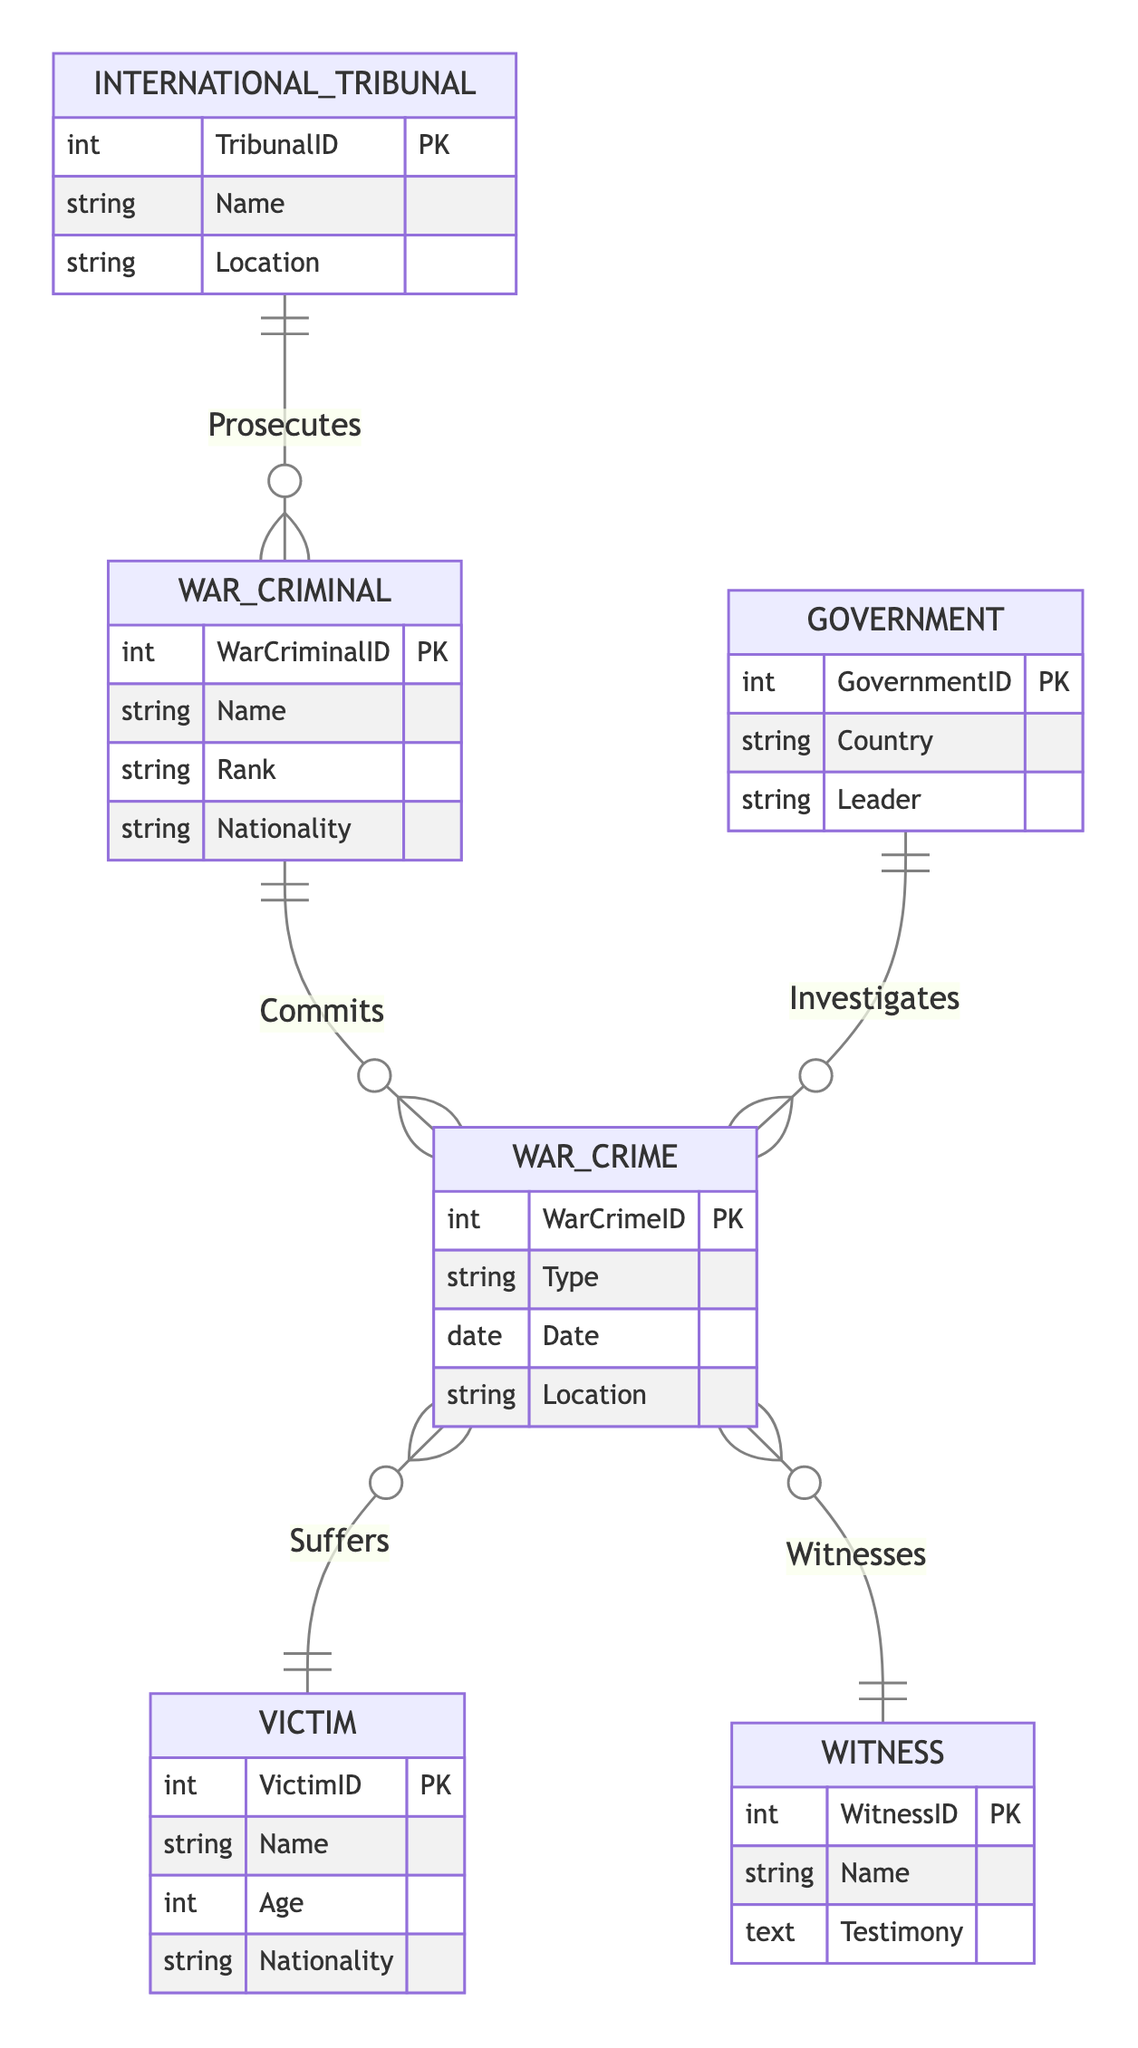What entity is involved in committing war crimes? The entity that represents individuals who commit war crimes is labeled "War Criminal". It directly connects to the "War Crime" entity through the "Commits" relationship.
Answer: War Criminal How many attributes does the War Crime entity have? The "War Crime" entity includes four attributes: WarCrimeID, Type, Date, and Location. By counting these, we find there are four attributes.
Answer: 4 What relationship connects Victims and War Crimes? The "Suffers" relationship connects "Victim" to "War Crime". This indicates that victims are those who are affected by war crimes.
Answer: Suffers Which entity prosecutes the War Criminals? The "International Tribunal" entity is responsible for prosecuting war criminals. It is connected to the "War Criminal" entity through the "Prosecutes" relationship.
Answer: International Tribunal What is the nature of the relationship between Government and War Crime? The relationship named "Investigates" establishes a link between "Government" and "War Crime". This indicates that governments take action to investigate war crimes.
Answer: Investigates How many entities are there in the diagram? By counting the listed entities—War Criminal, War Crime, Victim, Witness, International Tribunal, and Government—we find there are a total of six entities in the diagram.
Answer: 6 Which role does the Witness play in relation to War Crimes? The role of "Witness" is defined by the "Witnesses" relationship, which connects this entity to "War Crime". This means witnesses provide testimony regarding war crimes.
Answer: Witnesses What attribute describes the nationality of War Criminals? The attribute that reveals the nationality of war criminals is called "Nationality". This attribute is part of the "War Criminal" entity.
Answer: Nationality Which entity has a location attribute? The "International Tribunal" and "War Crime" entities both have "Location" as an attribute that describes where they are situated or where crimes occurred.
Answer: International Tribunal, War Crime What is the relationship between Witness and War Crime? The relationship is labeled "Witnesses". This indicates that witnesses provide testimony regarding specific incidents labeled as war crimes.
Answer: Witnesses 